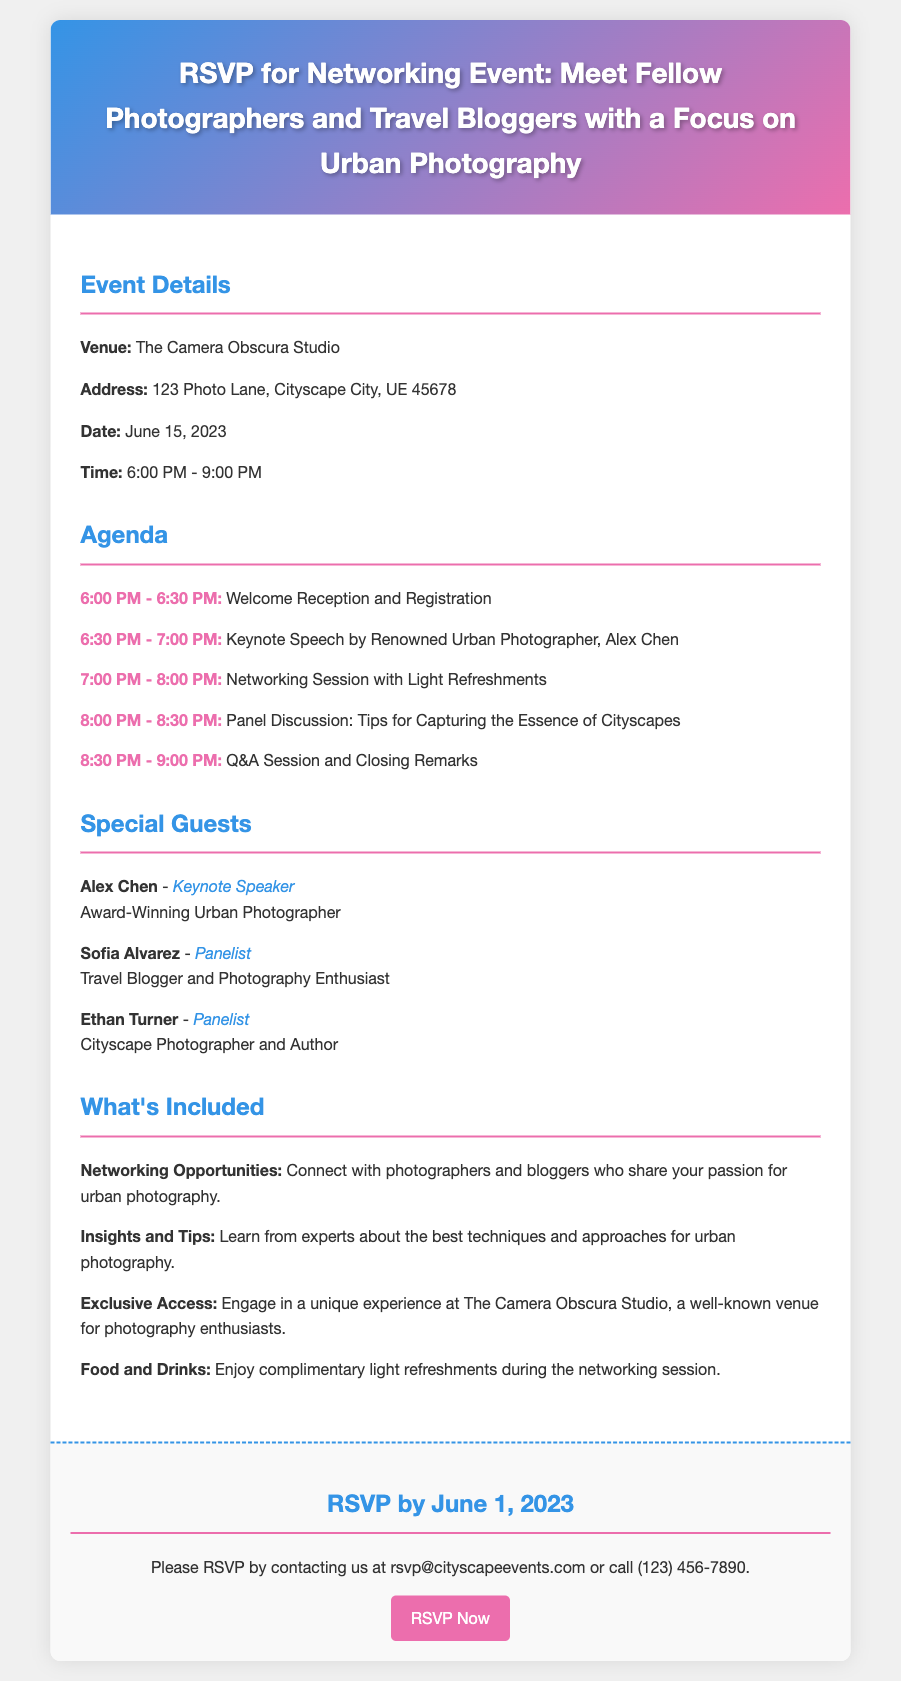What is the venue for the event? The venue for the event is stated as The Camera Obscura Studio.
Answer: The Camera Obscura Studio What date is the networking event scheduled for? The document specifies that the event is on June 15, 2023.
Answer: June 15, 2023 Who is the keynote speaker? The keynote speaker is identified in the document as Alex Chen.
Answer: Alex Chen What time does the networking session start? According to the agenda, the networking session starts at 7:00 PM.
Answer: 7:00 PM How many special guests are listed in the document? The document includes three special guests.
Answer: Three What is included in the networking opportunities? The document mentions that attendees can connect with photographers and bloggers who share their passion for urban photography.
Answer: Connect with photographers and bloggers What is the last date to RSVP? The document states that the last date to RSVP is June 1, 2023.
Answer: June 1, 2023 What type of refreshments will be provided? The document indicates that complimentary light refreshments will be enjoyed during the networking session.
Answer: Light refreshments What is the audience's focus at the event? The document highlights that the event focuses on urban photography.
Answer: Urban photography What happens during the 8:00 PM agenda item? The document describes that a panel discussion on tips for capturing the essence of cityscapes takes place at this time.
Answer: Panel Discussion: Tips for Capturing the Essence of Cityscapes 